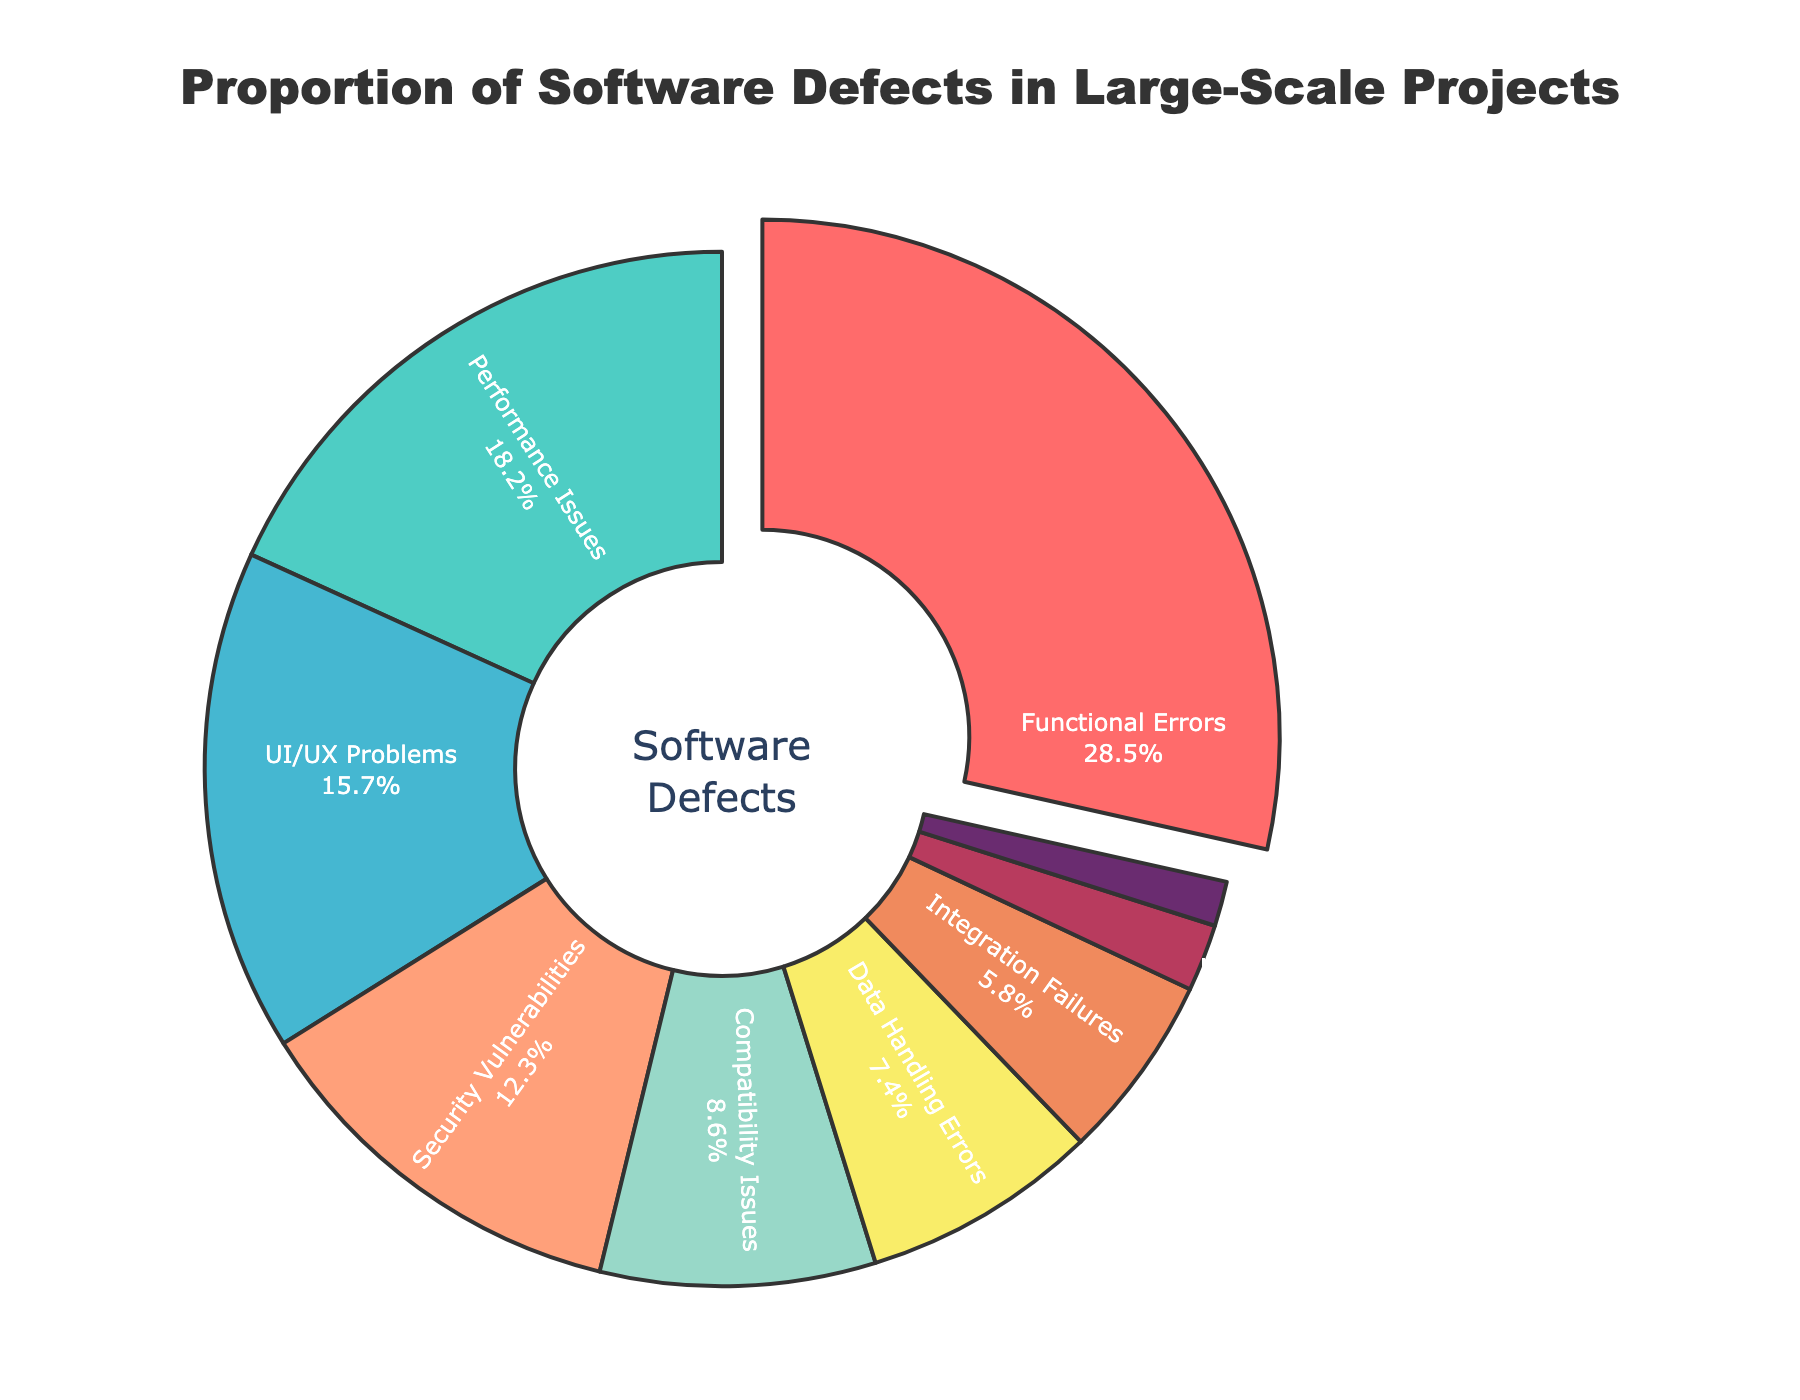Which defect type has the largest proportion? The figure highlights the section with the largest proportion by slightly pulling it away from the donut chart. The label and percentage displayed inside the pulled section shows the defect type with the largest proportion.
Answer: Functional Errors Which two defect types make up nearly half of the total defects? Identify the two largest sections of the donut chart by area, and then add their percentages. The two largest sections are for Functional Errors and Performance Issues. Summing their percentages (28.5% + 18.2%) gives 46.7%, which is nearly half of the total defects.
Answer: Functional Errors and Performance Issues What is the combined percentage of UI/UX Problems and Integration Failures? Locate the segments for UI/UX Problems (15.7%) and Integration Failures (5.8%). Add these percentages together: 15.7% + 5.8% = 21.5%.
Answer: 21.5% Which defect type has a smaller proportion: Data Handling Errors or Compatibility Issues? Compare the sections for Data Handling Errors (7.4%) and Compatibility Issues (8.6%). The segment with the label 7.4% is smaller, so Data Handling Errors have a smaller proportion.
Answer: Data Handling Errors What is the difference in percentage between Security Vulnerabilities and Localization Bugs? Locate the sections for Security Vulnerabilities (12.3%) and Localization Bugs (1.4%). Subtract the smaller percentage from the larger: 12.3% - 1.4% = 10.9%.
Answer: 10.9% Which color represents Performance Issues, and what is its percentage? Identify the section by label for Performance Issues and note its color. The Performance Issues label is attached to a turquoise segment, and its percentage is shown as 18.2%.
Answer: Turquoise, 18.2% How much larger is the proportion of Functional Errors compared to Documentation Inconsistencies? Identify the sections for Functional Errors (28.5%) and Documentation Inconsistencies (2.1%). Subtract the smaller percentage from the larger: 28.5% - 2.1% = 26.4%.
Answer: 26.4% What is the average percentage of the three smallest categories? Locate the three smallest segments: Localization Bugs (1.4%), Documentation Inconsistencies (2.1%), and Integration Failures (5.8%). Add these percentages and divide by 3: (1.4% + 2.1% + 5.8%) / 3 = 3.1%.
Answer: 3.1% Which defect types have a proportion greater than 10%? Identify the segments with labels showing percentages greater than 10%. These segments are Functional Errors (28.5%), Performance Issues (18.2%), UI/UX Problems (15.7%), and Security Vulnerabilities (12.3%).
Answer: Functional Errors, Performance Issues, UI/UX Problems, and Security Vulnerabilities 